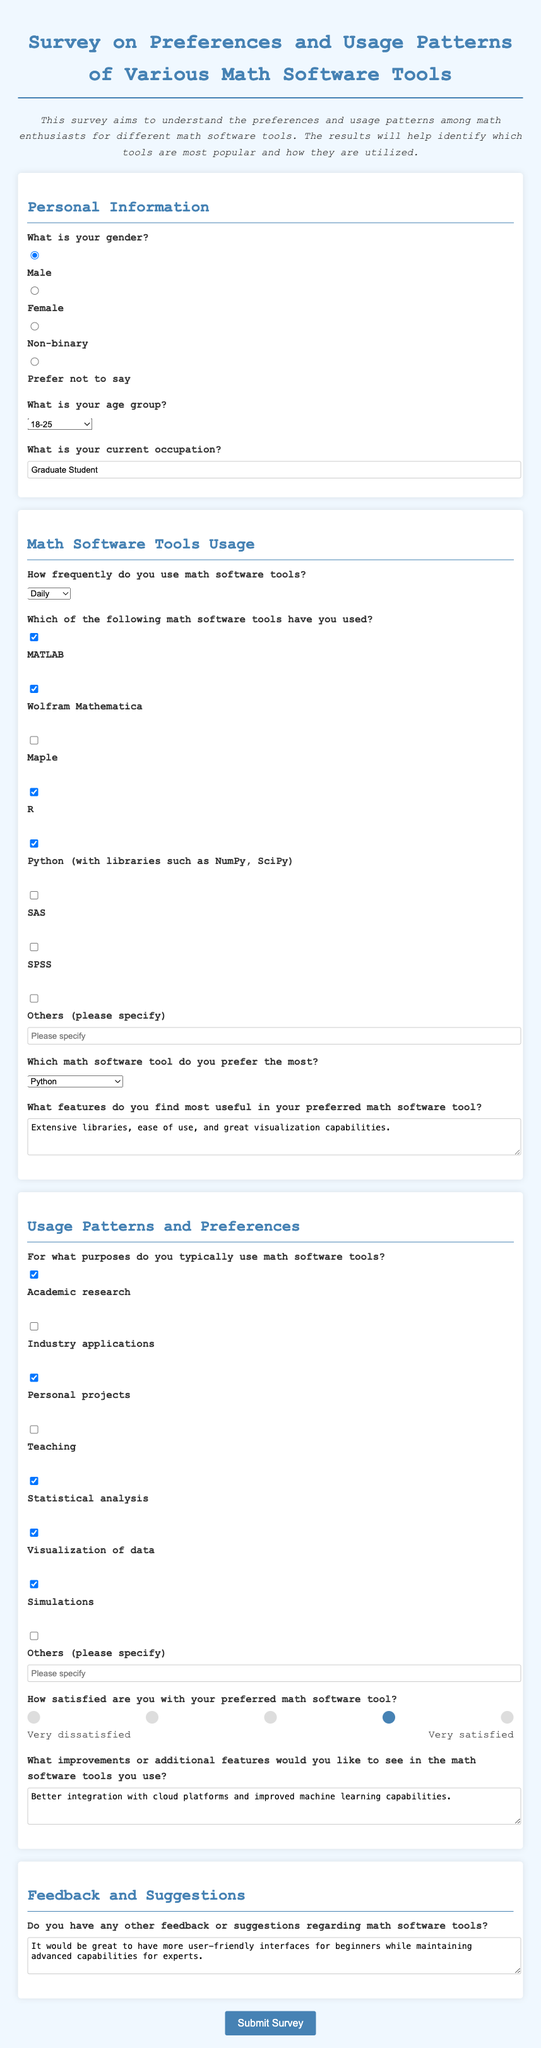What is the preferred math software tool of the respondent? The preferred math software tool is indicated in the survey responses, specifically stated in the "Which math software tool do you prefer the most?" section.
Answer: Python How frequently does the respondent use math software tools? This information is found under the "How frequently do you use math software tools?" question in the usage section.
Answer: Daily What is the age group of the respondent? The age group selection is mentioned in the "What is your age group?" section, indicating the demographic information of the respondent.
Answer: 18-25 What are some useful features mentioned for the preferred math software tool? The specific features regarded as useful are detailed in the "What features do you find most useful in your preferred math software tool?" section.
Answer: Extensive libraries, ease of use, and great visualization capabilities What level of satisfaction does the respondent express for their preferred math software tool? The satisfaction level is given in the "How satisfied are you with your preferred math software tool?" section represented by a rating scale.
Answer: 4 How many purposes of using math software tools has the respondent checked? The number of purposes checked is determined by counting the selected options under "For what purposes do you typically use math software tools?"
Answer: 6 What improvements does the respondent suggest for math software tools? This suggestion can be found in the "What improvements or additional features would you like to see in the math software tools you use?" section of the survey.
Answer: Better integration with cloud platforms and improved machine learning capabilities What is the respondent's current occupation? The occupation information is provided in the "What is your current occupation?" section, which reveals the professional background of the respondent.
Answer: Graduate Student What feedback does the respondent have regarding math software tools? This feedback is included in the last question of the survey concerning any additional comments or suggestions.
Answer: More user-friendly interfaces for beginners while maintaining advanced capabilities for experts 